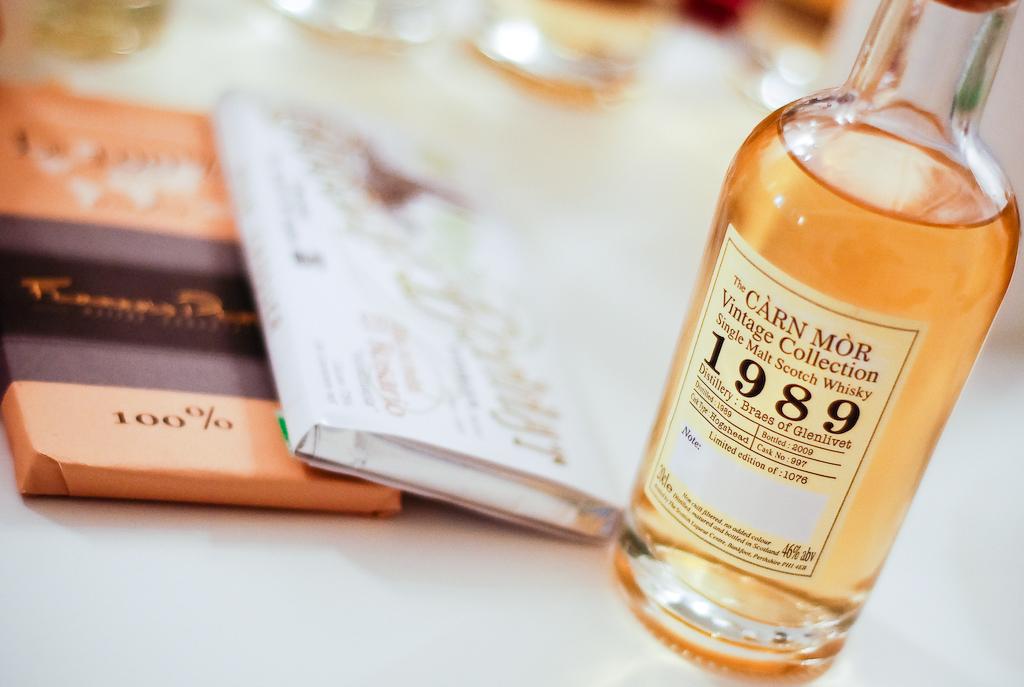What type of beverage is in the bottle?
Give a very brief answer. Whiskey. 